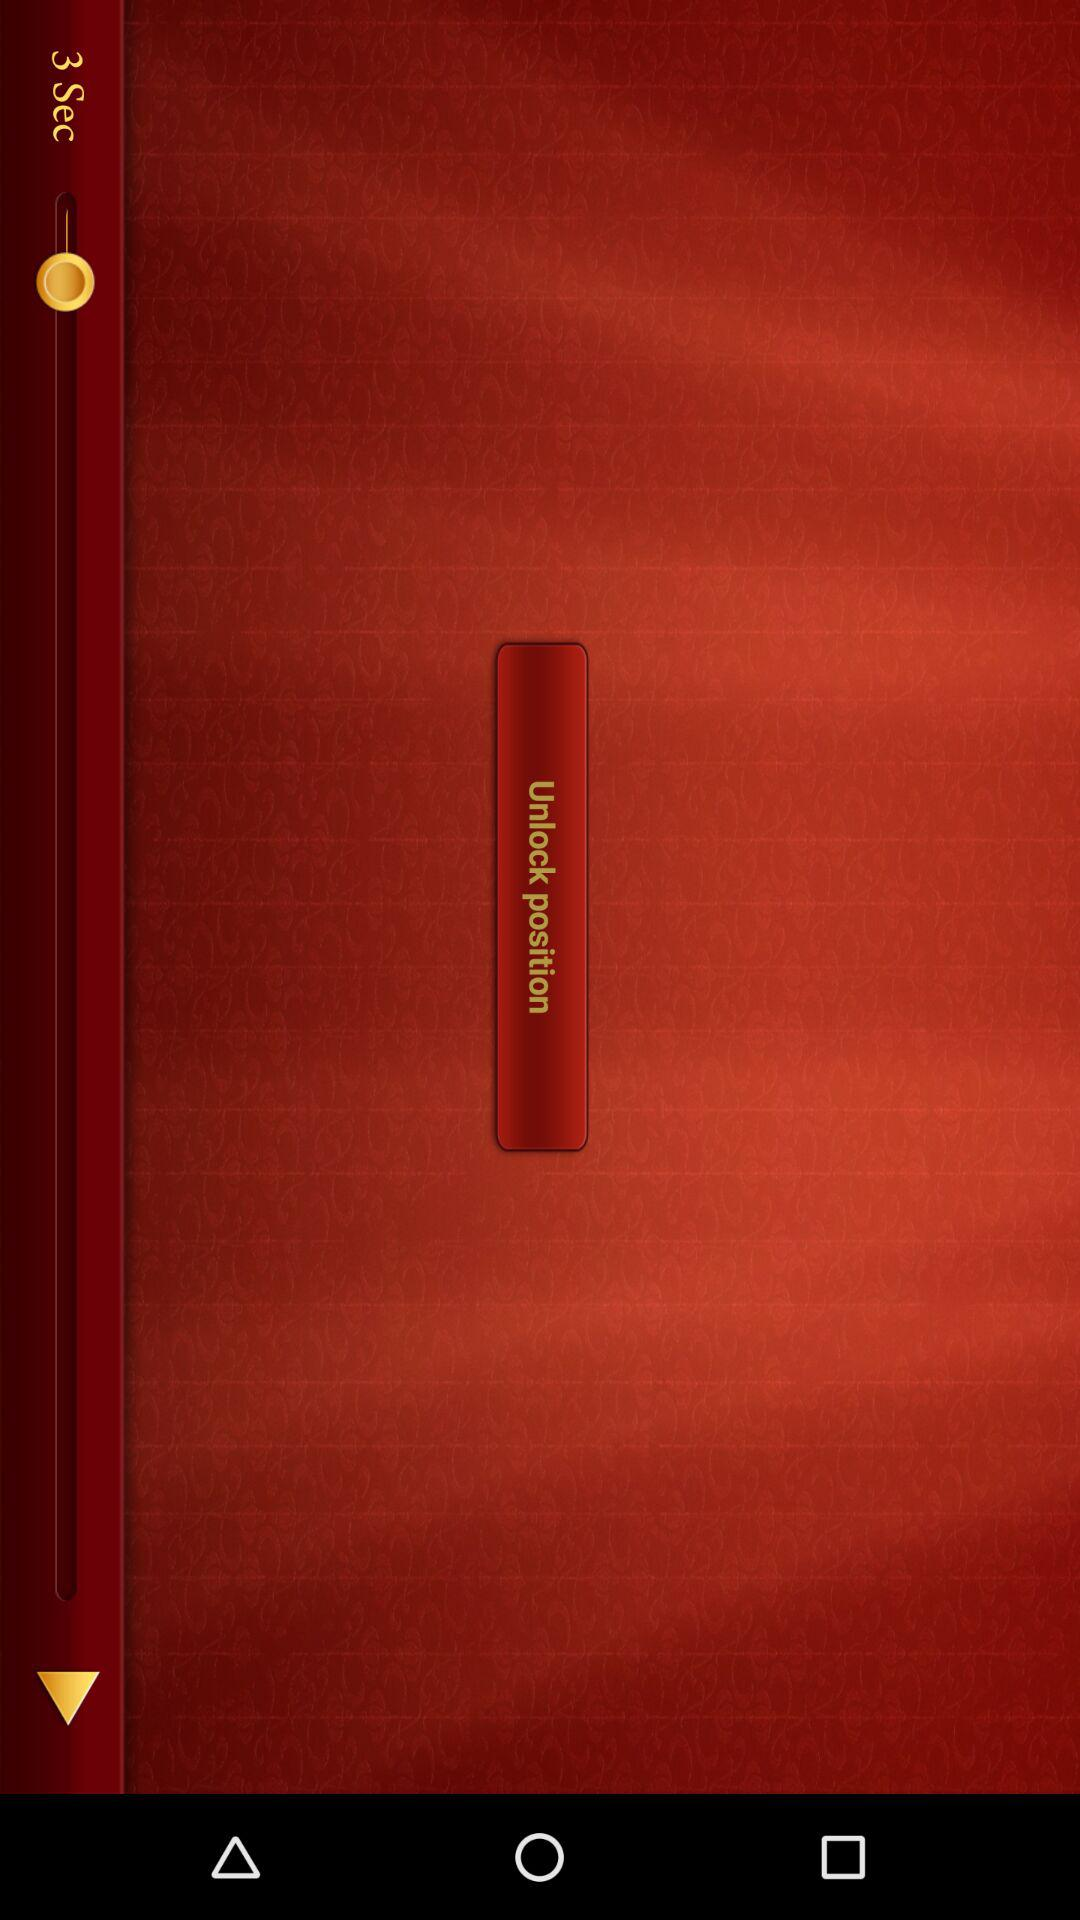Which category of "Ideas" is highlighted? The highlighted category is "Creative". 